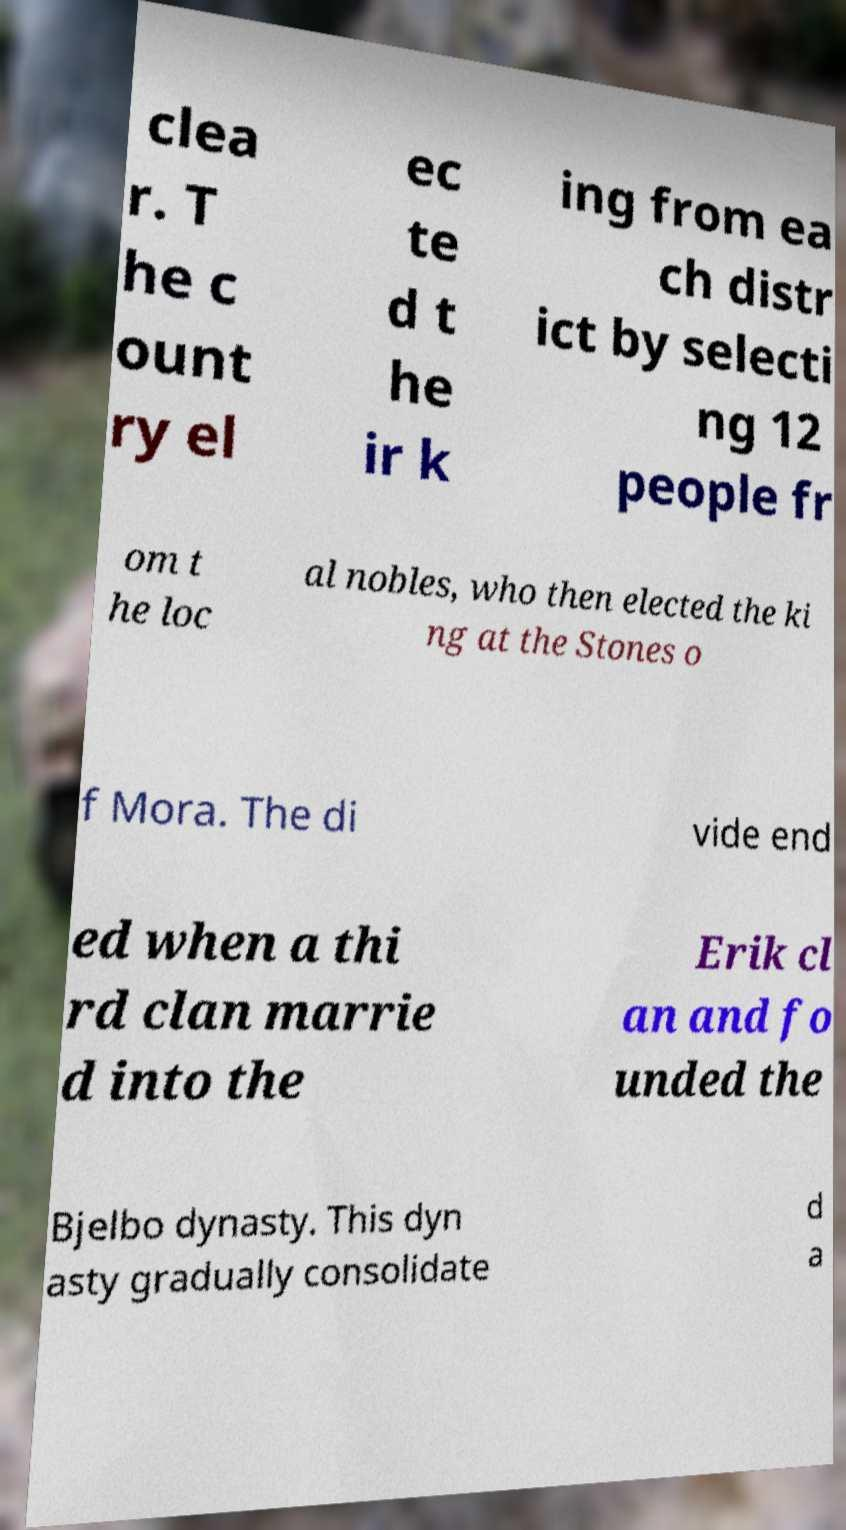There's text embedded in this image that I need extracted. Can you transcribe it verbatim? clea r. T he c ount ry el ec te d t he ir k ing from ea ch distr ict by selecti ng 12 people fr om t he loc al nobles, who then elected the ki ng at the Stones o f Mora. The di vide end ed when a thi rd clan marrie d into the Erik cl an and fo unded the Bjelbo dynasty. This dyn asty gradually consolidate d a 